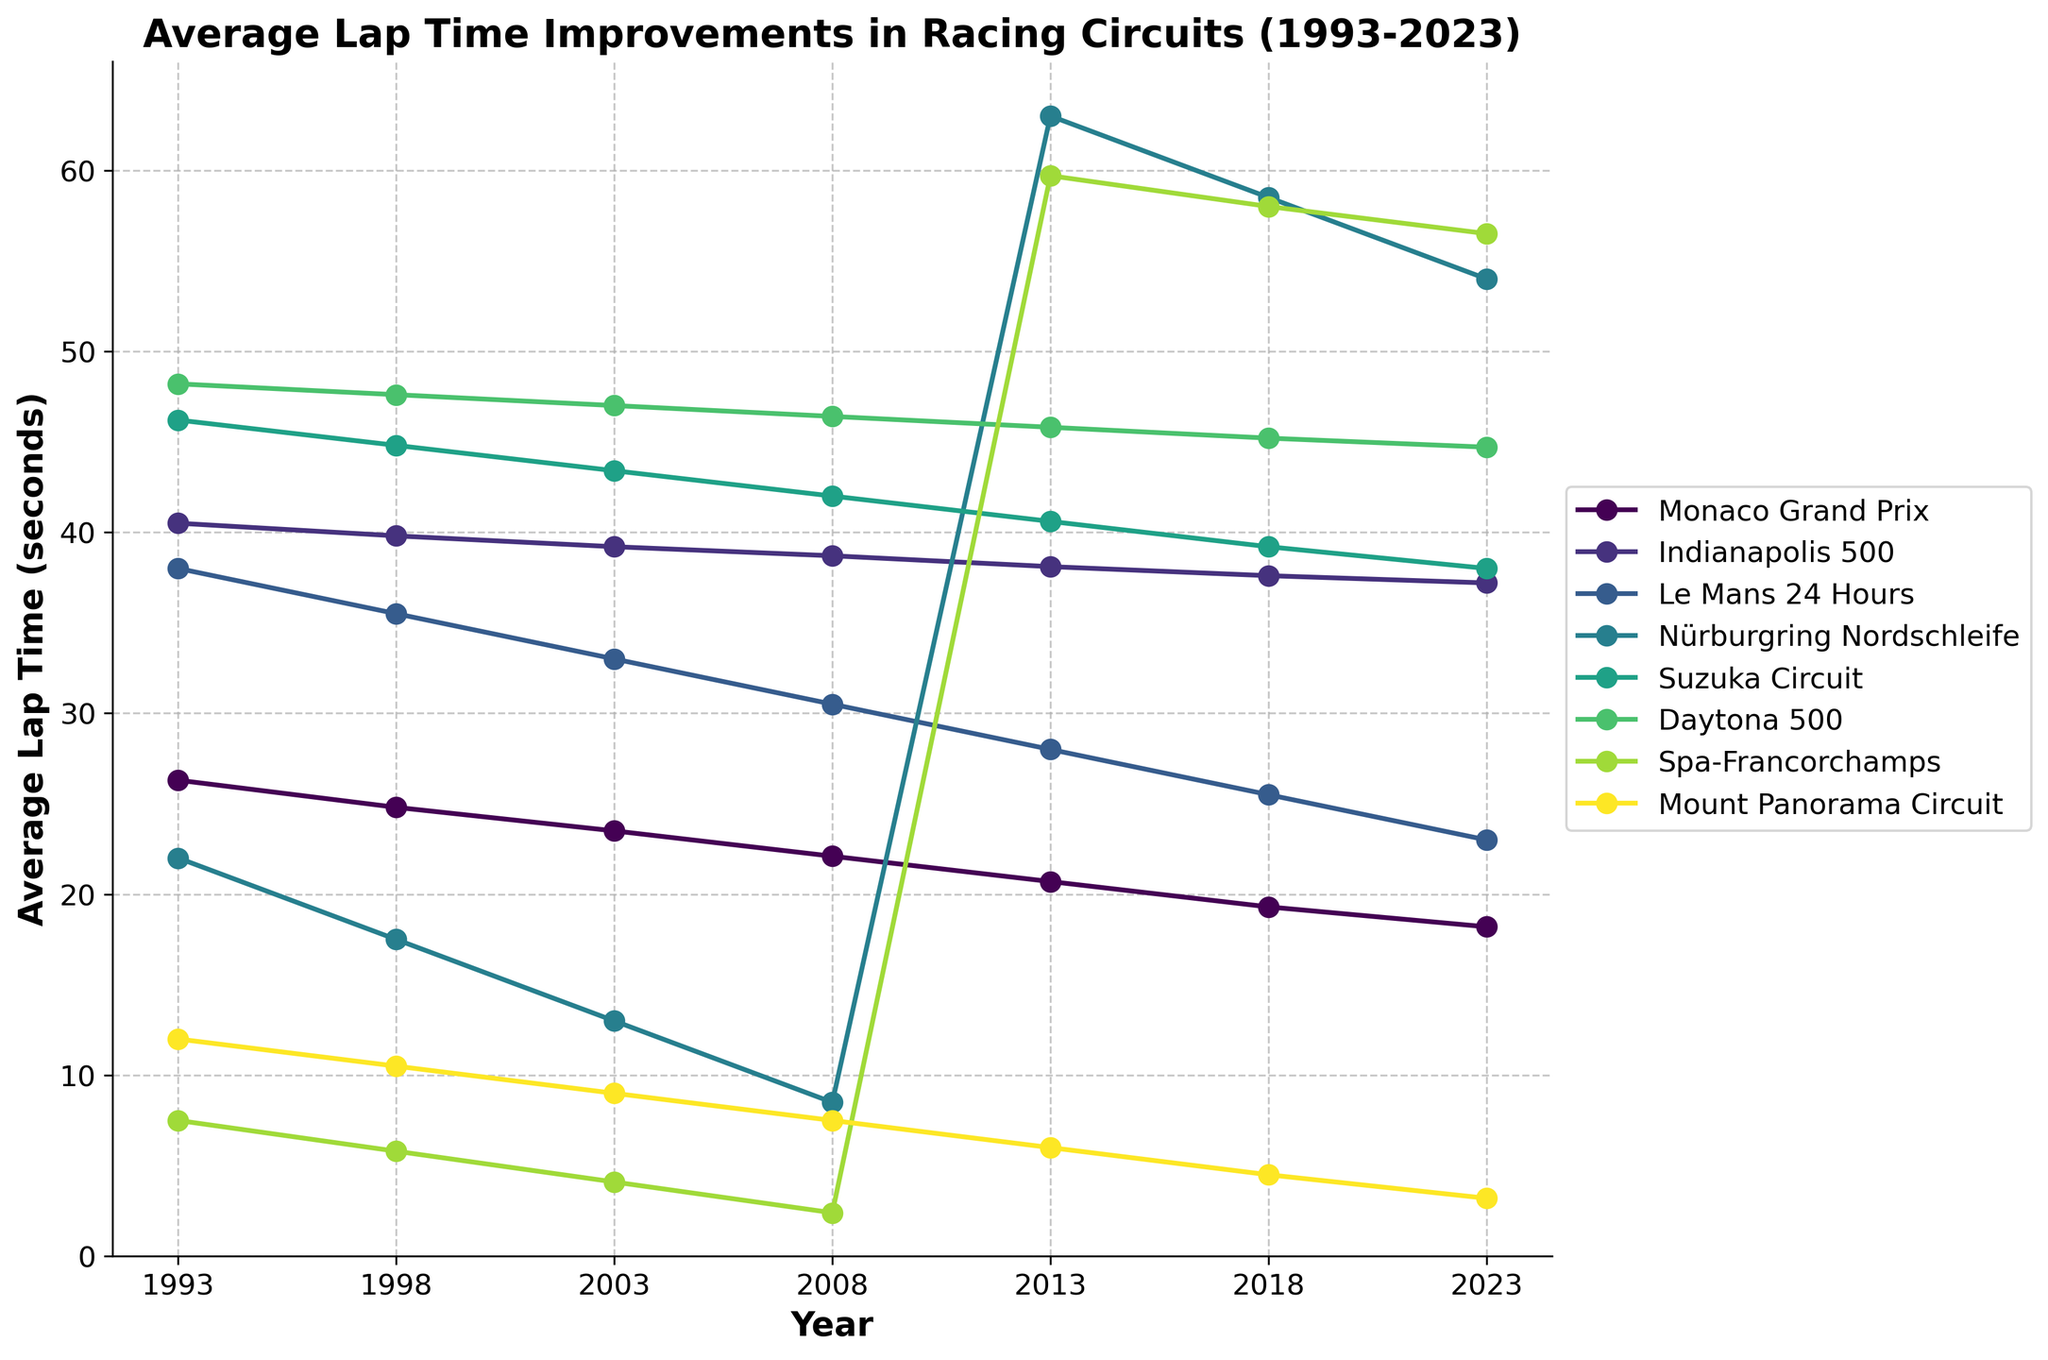What's the trend in average lap times for the Nürburgring Nordschleife from 1993 to 2023? The average lap time for the Nürburgring Nordschleife decreases from 1993 to 2023, indicating an improvement over the years. Initially, it is approximately 7:15 in 1993 and reduces to about 6:48 by 2023. This suggests continuous advancements in technology and racing performance.
Answer: The trend shows a consistent decrease Which circuit has the most significant reduction in average lap time over the 30 years? To find the circuit with the most significant reduction, subtract the 2023 time from the 1993 time for each circuit and compare the differences. The Nürburgring Nordschleife's lap time decreases from 7:15 to 6:48, a reduction of 27 seconds. Comparing all circuits, the Monaco Grand Prix reduces from 1:25.30 to 1:17.20, about 8.1 seconds, but the Nürburgring Nordschleife shows the largest reduction.
Answer: Nürburgring Nordschleife Which circuit had the least improvement in average lap times between 1993 and 2023? To determine the least improvement, calculate the difference in lap times between 1993 and 2023 for each circuit and find the smallest difference. The Indianapolis 500 changes from 40.50 to 37.20, indicating an improvement of 3.30 seconds, which appears to be the smallest compared to other circuits.
Answer: Indianapolis 500 In which year did the most significant improvement occur for the Suzuka Circuit? Examine the changes in average lap time for the Suzuka Circuit between consecutive years. The difference is most significant between 1993 (1:45.20) and 1998 (1:43.80), a reduction of 1.40 seconds. Checking other intervals, none surpass this value for the Suzuka Circuit.
Answer: 1993 to 1998 How does the improvement in lap times of the Monaco Grand Prix compare with the improvements of the Spa-Francorchamps over the years? Calculate the yearly improvements for each circuit and compare the trends. The Monaco Grand Prix shows consistent improvement: from 1:25.30 to 1:17.20. The Spa-Francorchamps reduces from 2:05.50 to 1:55.50. The overall improvement for Monaco is about 8.1 seconds, whereas Spa-Francorchamps improves by 10 seconds.
Answer: Monaco Grand Prix improves less than Spa-Francorchamps What is the average lap time for Le Mans 24 Hours across the given years? Sum the average lap times for Le Mans 24 Hours at each interval and divide by the number of years. Convert all lap times to seconds: (3:35:00 = 12900s, 3:32:50 = 12770s, etc.), then sum these: 12900 + 12770 + 12600 + 12450 + 12300 + 12150 + 12000 = 87170. Average: 87170/7 ≈ 12453 seconds, converting back to time format roughly 3:27.55.
Answer: Approximately 3:27.55 Which circuit’s progress pattern is visually represented by a darker color on the plot? The plot uses a colormap with circuits colored from light to dark. Typically, the last circuit in such plots has the darkest color. According to the data, Mount Panorama Circuit would likely be represented by a darker color.
Answer: Mount Panorama Circuit Considering only the final years on the graph for all circuits, which has the shortest average lap time in 2023? Look at the 2023 lap times for each circuit. The Indianapolis 500's lap time in 2023 is 37.20 seconds, the shortest among all listed circuits.
Answer: Indianapolis 500 